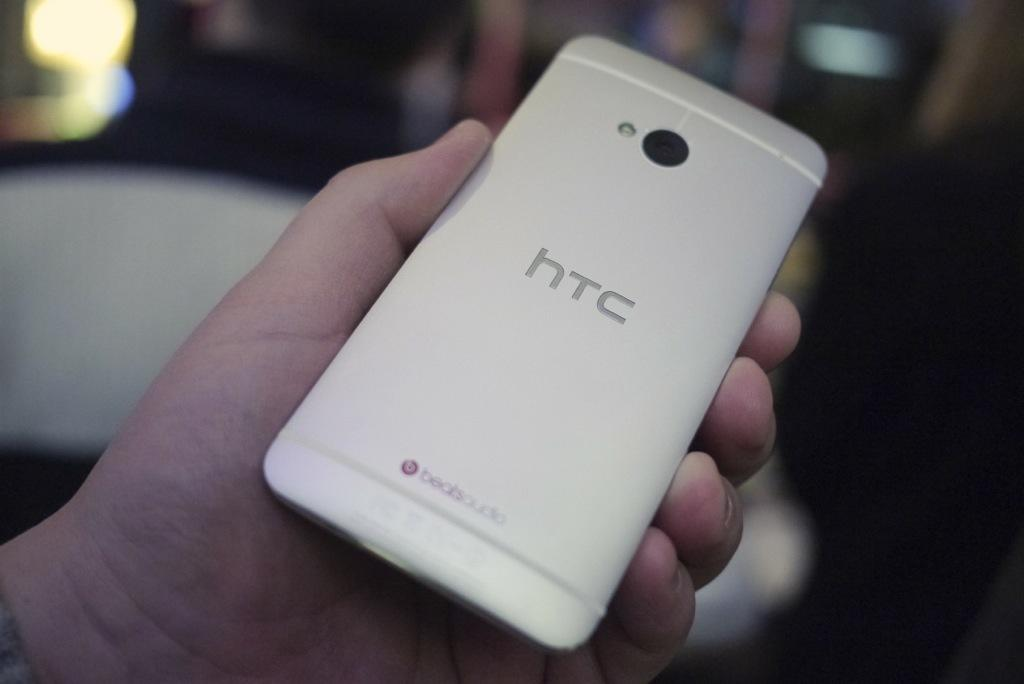Provide a one-sentence caption for the provided image. a person is holding a white HTC phone. 